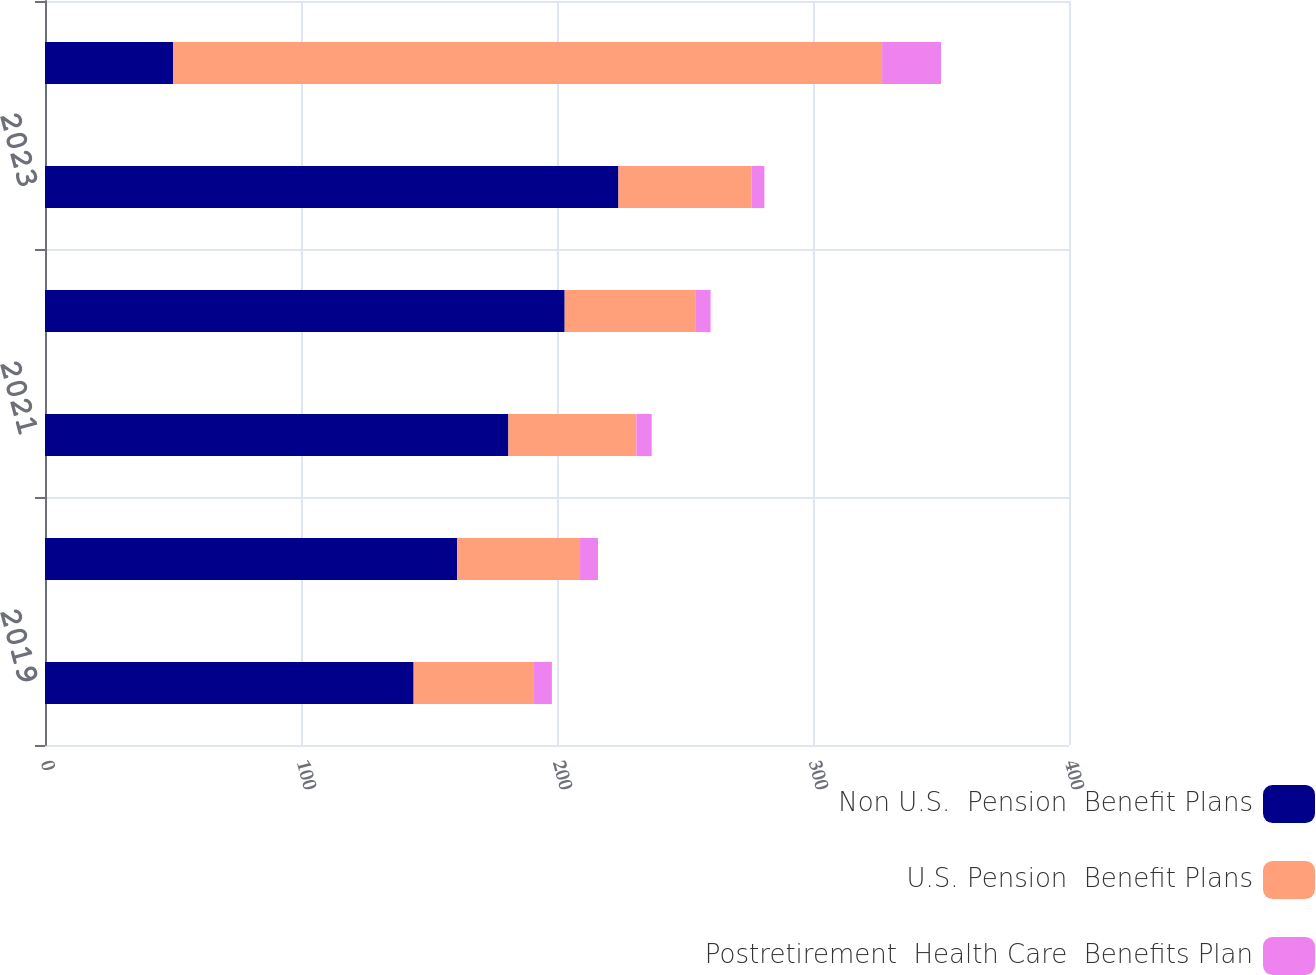Convert chart to OTSL. <chart><loc_0><loc_0><loc_500><loc_500><stacked_bar_chart><ecel><fcel>2019<fcel>2020<fcel>2021<fcel>2022<fcel>2023<fcel>2024-2028<nl><fcel>Non U.S.  Pension  Benefit Plans<fcel>144<fcel>161<fcel>181<fcel>203<fcel>224<fcel>50<nl><fcel>U.S. Pension  Benefit Plans<fcel>47<fcel>48<fcel>50<fcel>51<fcel>52<fcel>277<nl><fcel>Postretirement  Health Care  Benefits Plan<fcel>7<fcel>7<fcel>6<fcel>6<fcel>5<fcel>23<nl></chart> 